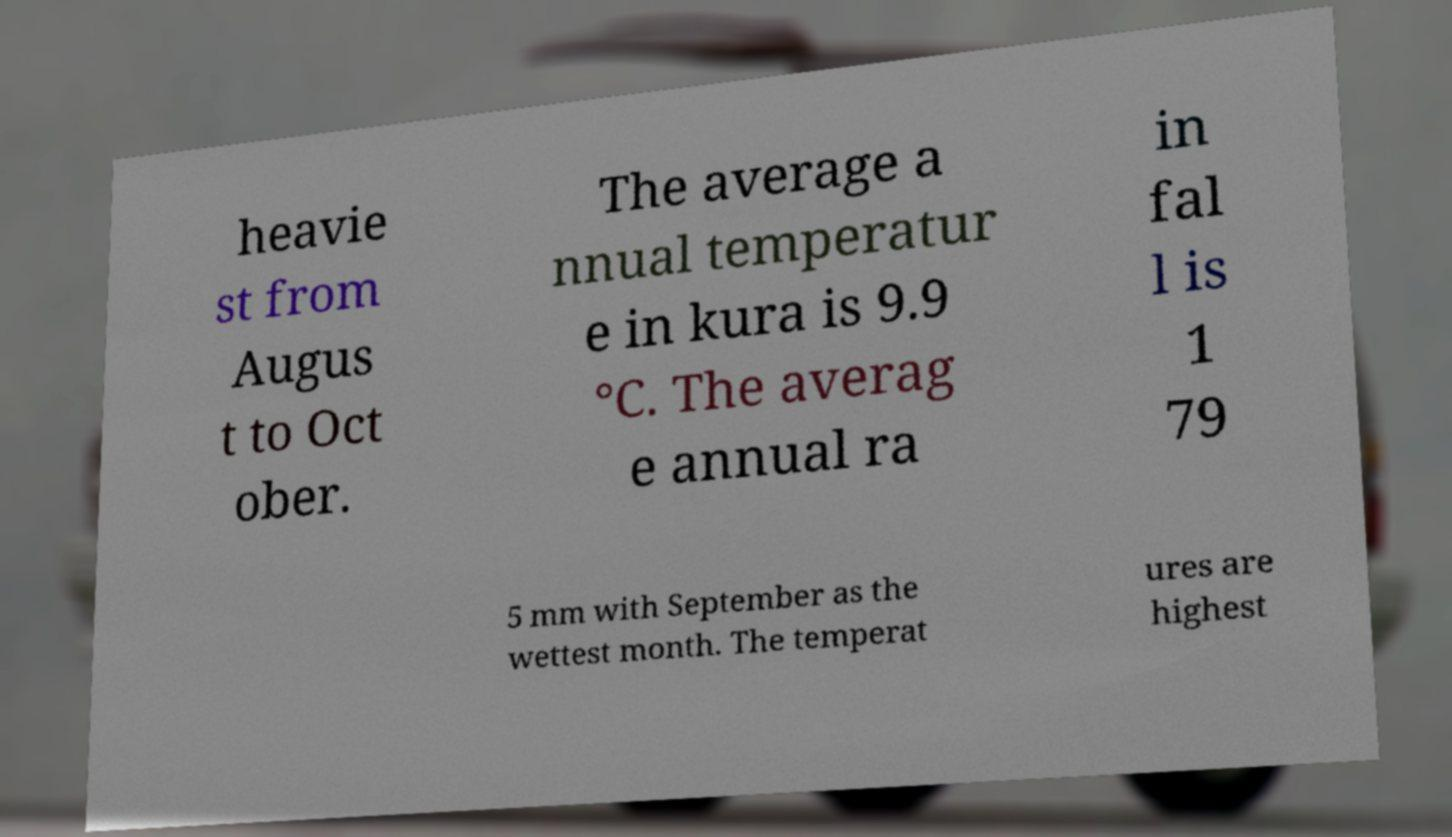Could you assist in decoding the text presented in this image and type it out clearly? heavie st from Augus t to Oct ober. The average a nnual temperatur e in kura is 9.9 °C. The averag e annual ra in fal l is 1 79 5 mm with September as the wettest month. The temperat ures are highest 